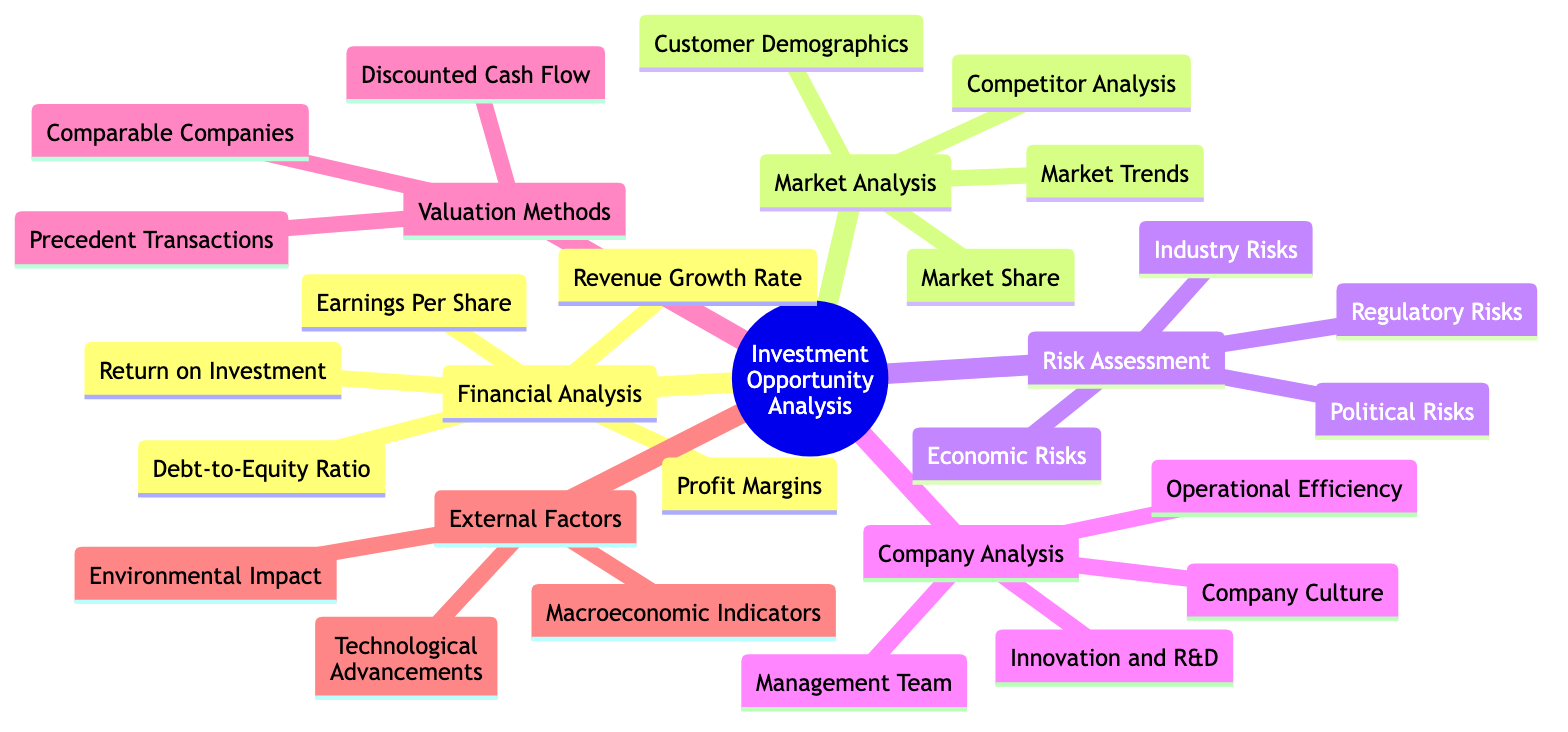what are the main categories of factors in this mind map? The diagram displays main categories, which include Financial Analysis, Market Analysis, Risk Assessment, Company Analysis, Valuation Methods, and External Factors.
Answer: Financial Analysis, Market Analysis, Risk Assessment, Company Analysis, Valuation Methods, External Factors how many nodes are in the Risk Assessment category? The Risk Assessment category contains four nodes: Economic Risks, Industry Risks, Political Risks, and Regulatory Risks. Counting these gives a total of four nodes.
Answer: 4 which analysis category contains the Debt-to-Equity Ratio? The Debt-to-Equity Ratio is located in the Financial Analysis category.
Answer: Financial Analysis name one of the valuation methods mentioned in the mind map. The mind map lists several valuation methods, including Discounted Cash Flow, Comparable Companies Analysis, and Precedent Transactions. One method is Discounted Cash Flow.
Answer: Discounted Cash Flow which category do Market Trends belong to? Market Trends is grouped under the Market Analysis category.
Answer: Market Analysis how are External Factors related to Investment Opportunity Analysis? The External Factors category provides insights that could impact investment opportunities, such as Macroeconomic Indicators, Technological Advancements, and Environmental Impact, making it essential for decision-making.
Answer: Impact investment opportunities what are the four types of risks included in the Risk Assessment category? The Risk Assessment category encompasses Economic Risks, Industry Risks, Political Risks, and Regulatory Risks. Listing these gives the answer.
Answer: Economic Risks, Industry Risks, Political Risks, Regulatory Risks how many nodes are listed under Company Analysis? The Company Analysis category lists four specific aspects: Management Team, Company Culture, Operational Efficiency, and Innovation and R&D. Counting gives a total of four nodes.
Answer: 4 name two components included in the Market Analysis category. The Market Analysis category includes various components, including Market Trends, Competitor Analysis, Market Share, and Customer Demographics. Two examples are Market Trends and Competitor Analysis.
Answer: Market Trends, Competitor Analysis which component in Financial Analysis is used to evaluate profitability? Among the components of Financial Analysis, Profit Margins are specifically used to evaluate a company's profitability.
Answer: Profit Margins 